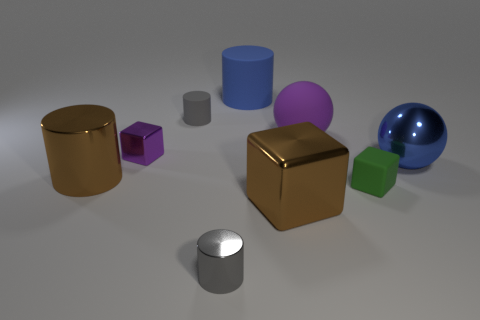Subtract all cubes. How many objects are left? 6 Add 7 small green cubes. How many small green cubes are left? 8 Add 1 matte cylinders. How many matte cylinders exist? 3 Subtract 0 cyan cylinders. How many objects are left? 9 Subtract all gray shiny cylinders. Subtract all blue metallic spheres. How many objects are left? 7 